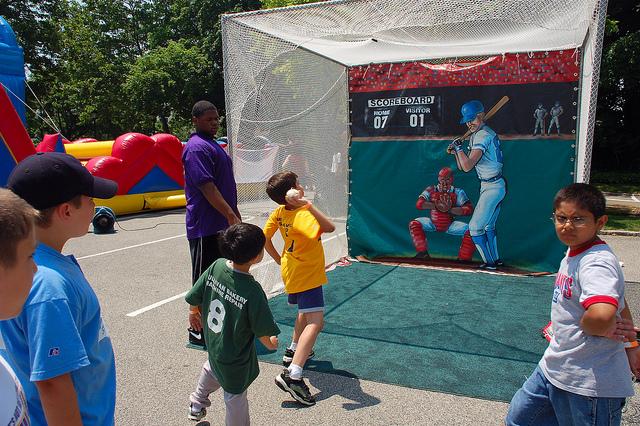Are the boys under five years old?
Be succinct. No. Is the man going to hit the ball?
Give a very brief answer. No. What sport are these kids playing?
Answer briefly. Baseball. This boy is pretending to do what to the ball?
Be succinct. Throw. 